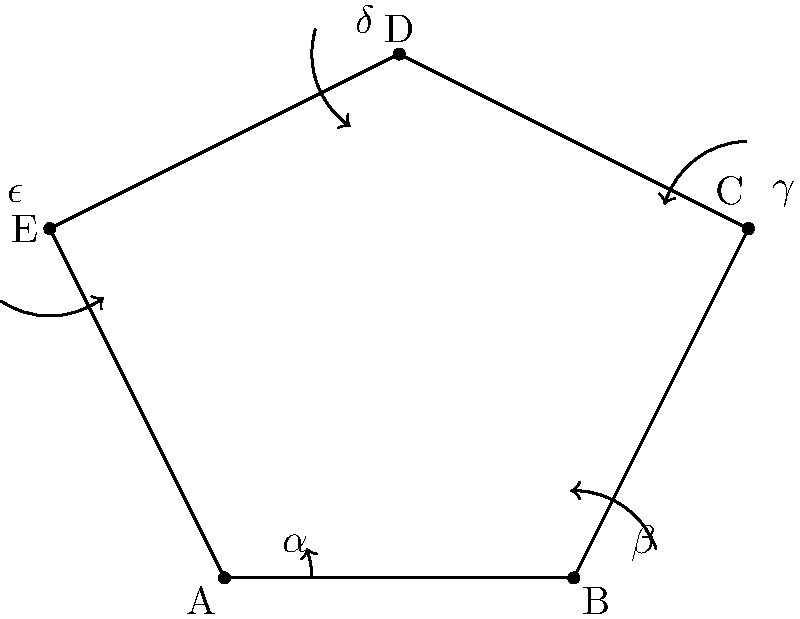Consider the convex pentagon ABCDE shown above. Let $\alpha$, $\beta$, $\gamma$, $\delta$, and $\epsilon$ represent the measures of the exterior angles at vertices A, B, C, D, and E, respectively. Prove that $\alpha + \beta + \gamma + \delta + \epsilon = 360°$, and generalize this result for a convex polygon with $n$ sides. Let's approach this step-by-step:

1) In any polygon, the sum of the interior angles and the corresponding exterior angle at each vertex is 180°. This is because they form a straight line.

2) Let's denote the interior angles as $a$, $b$, $c$, $d$, and $e$. We can write:

   $a + \alpha = 180°$
   $b + \beta = 180°$
   $c + \gamma = 180°$
   $d + \delta = 180°$
   $e + \epsilon = 180°$

3) Adding these equations:

   $(a + b + c + d + e) + (\alpha + \beta + \gamma + \delta + \epsilon) = 5 * 180°$

4) We know that the sum of interior angles of a pentagon is $(5-2) * 180° = 540°$. So:

   $540° + (\alpha + \beta + \gamma + \delta + \epsilon) = 5 * 180° = 900°$

5) Subtracting 540° from both sides:

   $\alpha + \beta + \gamma + \delta + \epsilon = 900° - 540° = 360°$

6) To generalize for an $n$-sided polygon:
   - The sum of interior angles is $(n-2) * 180°$
   - The sum of all angles (interior + exterior) is $n * 180°$

7) Therefore:

   $(n-2) * 180° + $ (sum of exterior angles) $= n * 180°$

8) Solving this:

   (sum of exterior angles) $= n * 180° - (n-2) * 180°$
                             $= (n - n + 2) * 180°$
                             $= 2 * 180°$
                             $= 360°$

Thus, for any convex polygon, the sum of the exterior angles is always 360°.
Answer: $360°$ 